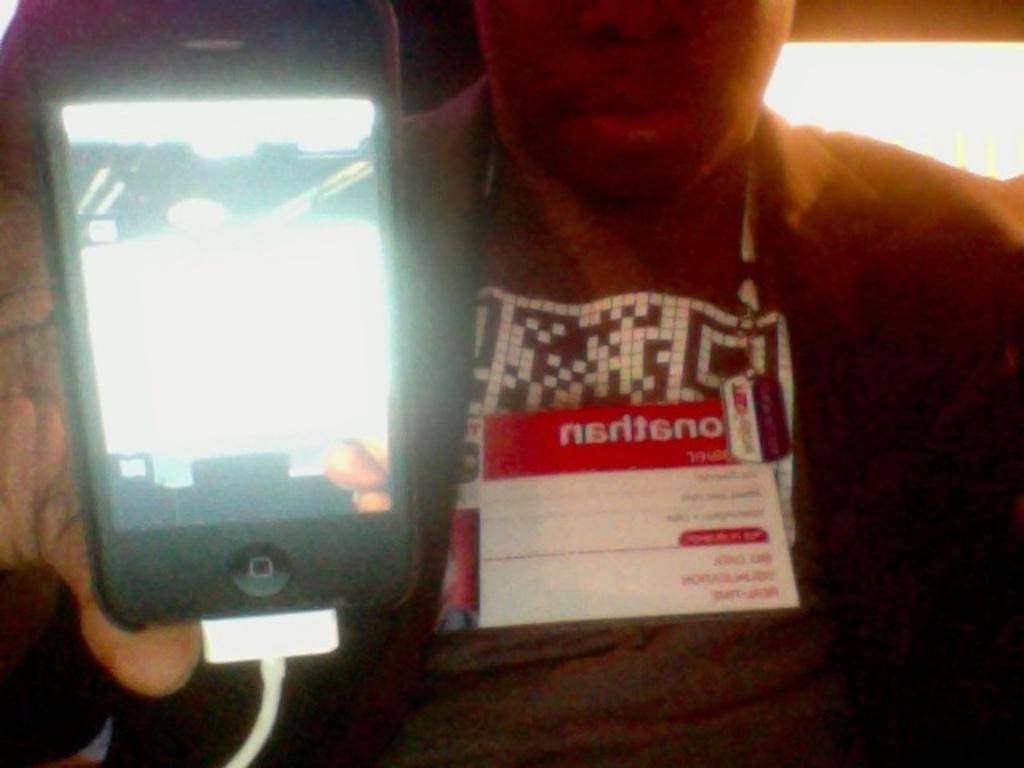Who or what is present in the image? There is a person in the image. What is the person holding in the image? The person is holding a mobile in the image. What is the mobile connected to in the image? The mobile is connected to a charger in the image. What can be seen on the person in the image? The person has an ID card in the image. What is visible in the background of the image? There is a light in the background of the image. What type of bread is the dog eating in the image? There is no dog or bread present in the image. What authority figure is depicted in the image? There is no authority figure depicted in the image; it features a person holding a mobile connected to a charger. 